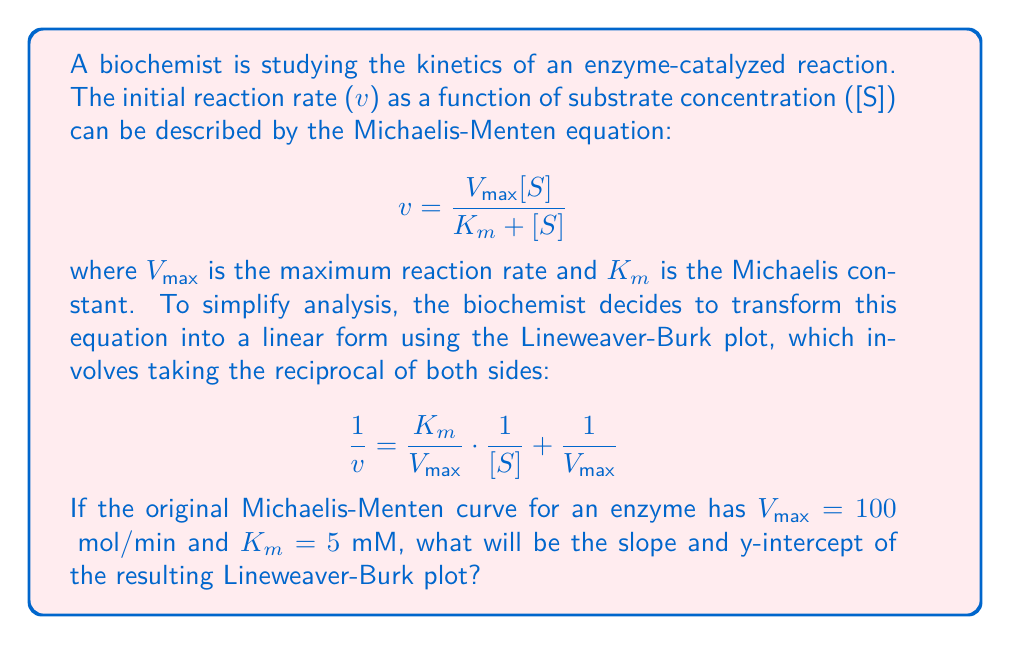Can you answer this question? To solve this problem, we need to analyze the transformation from the Michaelis-Menten equation to the Lineweaver-Burk plot and identify the corresponding parameters. Let's break it down step-by-step:

1. The Lineweaver-Burk equation is in the form of a straight line:
   $$y = mx + b$$
   where $y = \frac{1}{v}$, $x = \frac{1}{[S]}$, $m = \frac{K_m}{V_{max}}$, and $b = \frac{1}{V_{max}}$

2. We are given:
   $V_{max} = 100$ μmol/min
   $K_m = 5$ mM

3. To find the slope (m):
   $$m = \frac{K_m}{V_{max}} = \frac{5 \text{ mM}}{100 \text{ μmol/min}} = 0.05 \text{ mM}\cdot\text{min}/\text{μmol}$$

4. To find the y-intercept (b):
   $$b = \frac{1}{V_{max}} = \frac{1}{100 \text{ μmol/min}} = 0.01 \text{ min}/\text{μmol}$$

5. The units for the slope and y-intercept are different because the Lineweaver-Burk plot uses reciprocal units. The x-axis is in (mM)^(-1), and the y-axis is in (μmol/min)^(-1).

Thus, the Lineweaver-Burk plot will be a straight line with a slope of 0.05 mM·min/μmol and a y-intercept of 0.01 min/μmol.
Answer: Slope: 0.05 mM·min/μmol
Y-intercept: 0.01 min/μmol 